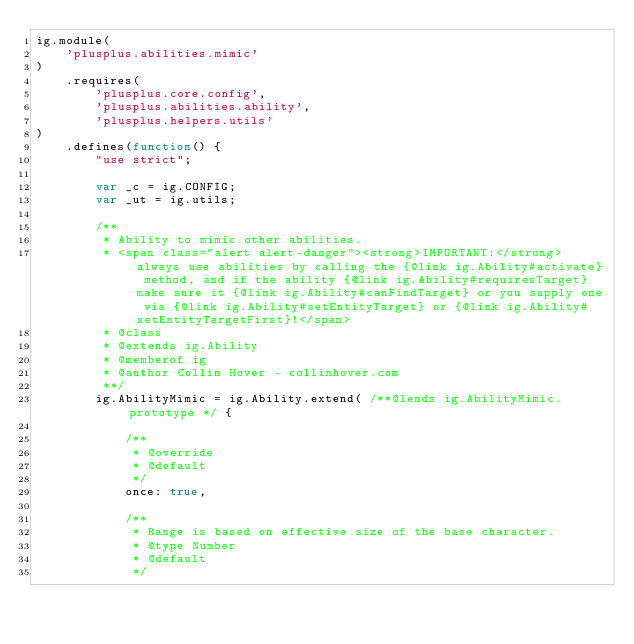<code> <loc_0><loc_0><loc_500><loc_500><_JavaScript_>ig.module(
    'plusplus.abilities.mimic'
)
    .requires(
        'plusplus.core.config',
        'plusplus.abilities.ability',
        'plusplus.helpers.utils'
)
    .defines(function() {
        "use strict";

        var _c = ig.CONFIG;
        var _ut = ig.utils;

        /**
         * Ability to mimic other abilities.
         * <span class="alert alert-danger"><strong>IMPORTANT:</strong> always use abilities by calling the {@link ig.Ability#activate} method, and if the ability {@link ig.Ability#requiresTarget} make sure it {@link ig.Ability#canFindTarget} or you supply one via {@link ig.Ability#setEntityTarget} or {@link ig.Ability#setEntityTargetFirst}!</span>
         * @class
         * @extends ig.Ability
         * @memberof ig
         * @author Collin Hover - collinhover.com
         **/
        ig.AbilityMimic = ig.Ability.extend( /**@lends ig.AbilityMimic.prototype */ {

            /**
             * @override
             * @default
             */
            once: true,

            /**
             * Range is based on effective size of the base character.
             * @type Number
             * @default
             */</code> 